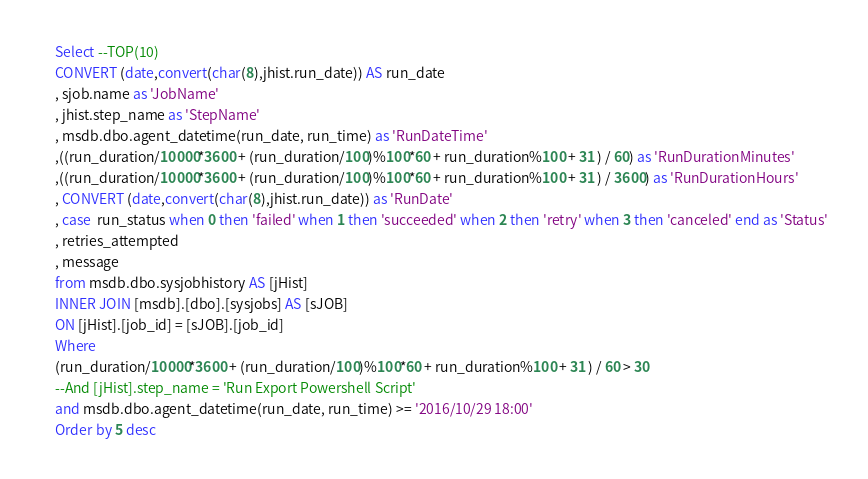<code> <loc_0><loc_0><loc_500><loc_500><_SQL_>Select --TOP(10)
CONVERT (date,convert(char(8),jhist.run_date)) AS run_date
, sjob.name as 'JobName'
, jhist.step_name as 'StepName'
, msdb.dbo.agent_datetime(run_date, run_time) as 'RunDateTime'
,((run_duration/10000*3600 + (run_duration/100)%100*60 + run_duration%100 + 31 ) / 60) as 'RunDurationMinutes'
,((run_duration/10000*3600 + (run_duration/100)%100*60 + run_duration%100 + 31 ) / 3600) as 'RunDurationHours'
, CONVERT (date,convert(char(8),jhist.run_date)) as 'RunDate'
, case  run_status when 0 then 'failed' when 1 then 'succeeded' when 2 then 'retry' when 3 then 'canceled' end as 'Status'
, retries_attempted
, message
from msdb.dbo.sysjobhistory AS [jHist]
INNER JOIN [msdb].[dbo].[sysjobs] AS [sJOB]
ON [jHist].[job_id] = [sJOB].[job_id]
Where 
(run_duration/10000*3600 + (run_duration/100)%100*60 + run_duration%100 + 31 ) / 60 > 30
--And [jHist].step_name = 'Run Export Powershell Script'
and msdb.dbo.agent_datetime(run_date, run_time) >= '2016/10/29 18:00'
Order by 5 desc</code> 